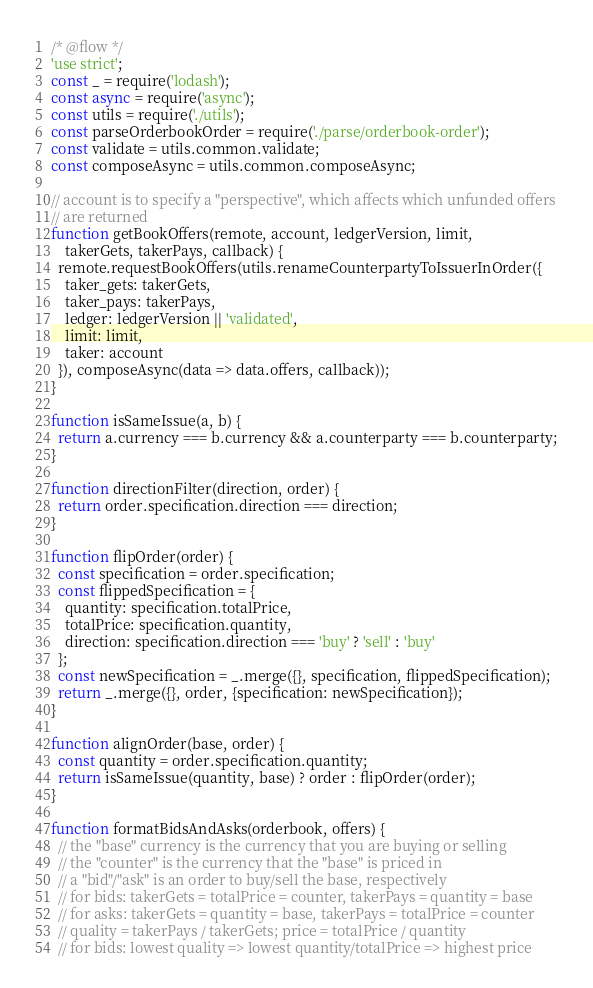<code> <loc_0><loc_0><loc_500><loc_500><_JavaScript_>/* @flow */
'use strict';
const _ = require('lodash');
const async = require('async');
const utils = require('./utils');
const parseOrderbookOrder = require('./parse/orderbook-order');
const validate = utils.common.validate;
const composeAsync = utils.common.composeAsync;

// account is to specify a "perspective", which affects which unfunded offers
// are returned
function getBookOffers(remote, account, ledgerVersion, limit,
    takerGets, takerPays, callback) {
  remote.requestBookOffers(utils.renameCounterpartyToIssuerInOrder({
    taker_gets: takerGets,
    taker_pays: takerPays,
    ledger: ledgerVersion || 'validated',
    limit: limit,
    taker: account
  }), composeAsync(data => data.offers, callback));
}

function isSameIssue(a, b) {
  return a.currency === b.currency && a.counterparty === b.counterparty;
}

function directionFilter(direction, order) {
  return order.specification.direction === direction;
}

function flipOrder(order) {
  const specification = order.specification;
  const flippedSpecification = {
    quantity: specification.totalPrice,
    totalPrice: specification.quantity,
    direction: specification.direction === 'buy' ? 'sell' : 'buy'
  };
  const newSpecification = _.merge({}, specification, flippedSpecification);
  return _.merge({}, order, {specification: newSpecification});
}

function alignOrder(base, order) {
  const quantity = order.specification.quantity;
  return isSameIssue(quantity, base) ? order : flipOrder(order);
}

function formatBidsAndAsks(orderbook, offers) {
  // the "base" currency is the currency that you are buying or selling
  // the "counter" is the currency that the "base" is priced in
  // a "bid"/"ask" is an order to buy/sell the base, respectively
  // for bids: takerGets = totalPrice = counter, takerPays = quantity = base
  // for asks: takerGets = quantity = base, takerPays = totalPrice = counter
  // quality = takerPays / takerGets; price = totalPrice / quantity
  // for bids: lowest quality => lowest quantity/totalPrice => highest price</code> 